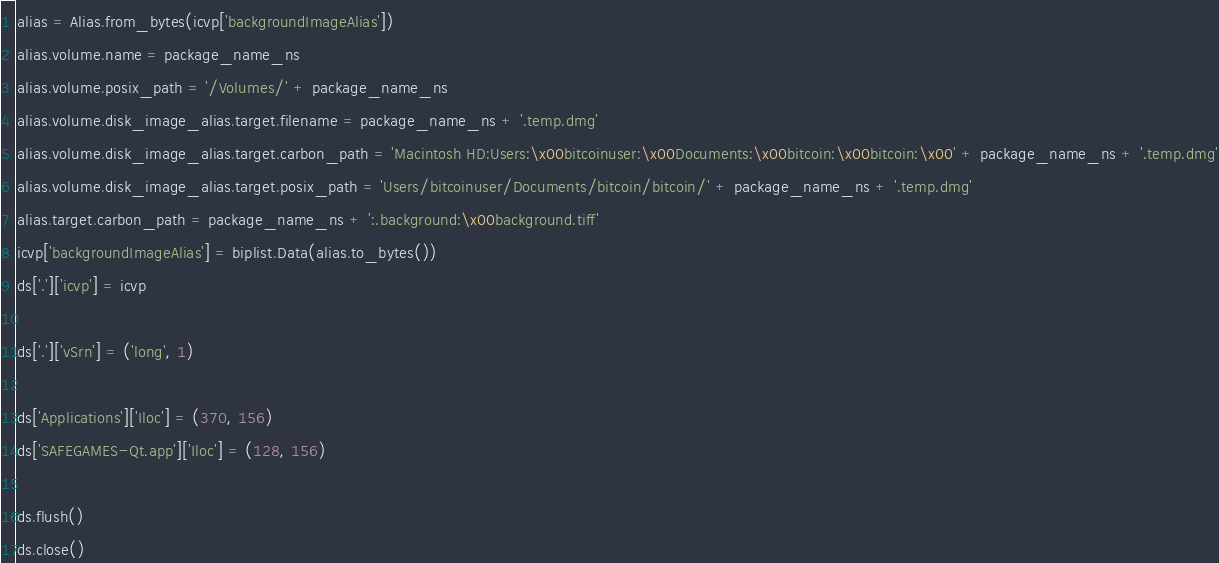<code> <loc_0><loc_0><loc_500><loc_500><_Python_>alias = Alias.from_bytes(icvp['backgroundImageAlias'])
alias.volume.name = package_name_ns
alias.volume.posix_path = '/Volumes/' + package_name_ns
alias.volume.disk_image_alias.target.filename = package_name_ns + '.temp.dmg'
alias.volume.disk_image_alias.target.carbon_path = 'Macintosh HD:Users:\x00bitcoinuser:\x00Documents:\x00bitcoin:\x00bitcoin:\x00' + package_name_ns + '.temp.dmg'
alias.volume.disk_image_alias.target.posix_path = 'Users/bitcoinuser/Documents/bitcoin/bitcoin/' + package_name_ns + '.temp.dmg'
alias.target.carbon_path = package_name_ns + ':.background:\x00background.tiff'
icvp['backgroundImageAlias'] = biplist.Data(alias.to_bytes())
ds['.']['icvp'] = icvp

ds['.']['vSrn'] = ('long', 1)

ds['Applications']['Iloc'] = (370, 156)
ds['SAFEGAMES-Qt.app']['Iloc'] = (128, 156)

ds.flush()
ds.close()
</code> 